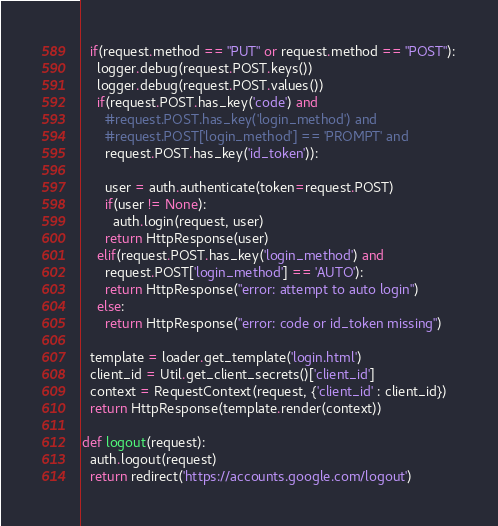<code> <loc_0><loc_0><loc_500><loc_500><_Python_>  if(request.method == "PUT" or request.method == "POST"):
    logger.debug(request.POST.keys())
    logger.debug(request.POST.values())
    if(request.POST.has_key('code') and 
      #request.POST.has_key('login_method') and 
      #request.POST['login_method'] == 'PROMPT' and
      request.POST.has_key('id_token')):

      user = auth.authenticate(token=request.POST)
      if(user != None):
        auth.login(request, user)
      return HttpResponse(user)
    elif(request.POST.has_key('login_method') and 
      request.POST['login_method'] == 'AUTO'):
      return HttpResponse("error: attempt to auto login")
    else:
      return HttpResponse("error: code or id_token missing")
    
  template = loader.get_template('login.html')
  client_id = Util.get_client_secrets()['client_id']
  context = RequestContext(request, {'client_id' : client_id})
  return HttpResponse(template.render(context))

def logout(request):
  auth.logout(request)
  return redirect('https://accounts.google.com/logout') 
</code> 